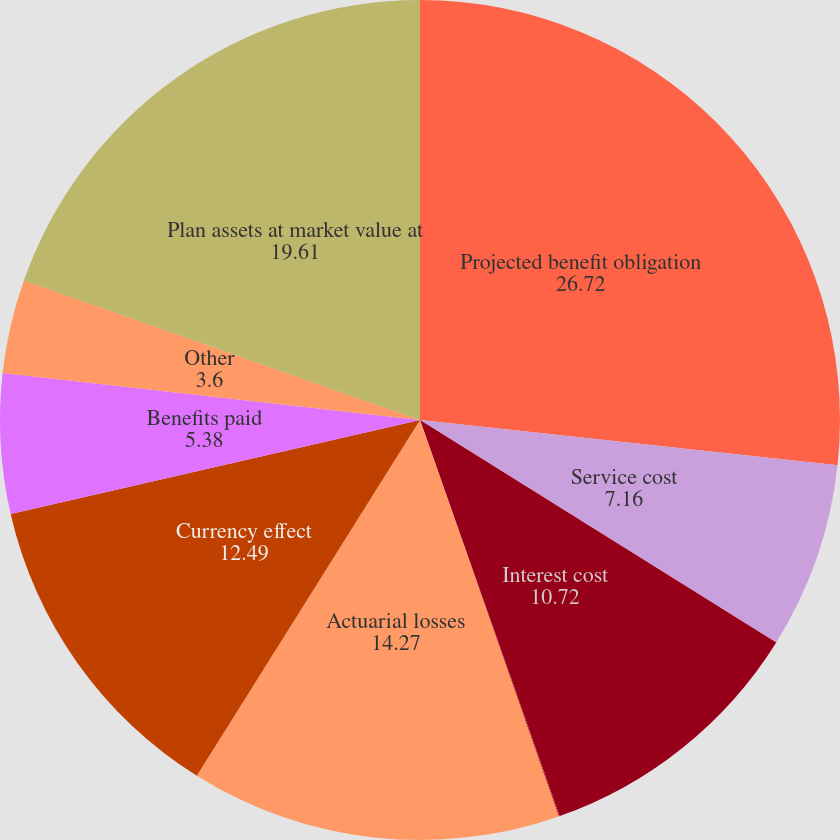Convert chart. <chart><loc_0><loc_0><loc_500><loc_500><pie_chart><fcel>Projected benefit obligation<fcel>Service cost<fcel>Interest cost<fcel>Contributions by Plan<fcel>Actuarial losses<fcel>Currency effect<fcel>Benefits paid<fcel>Other<fcel>Plan assets at market value at<nl><fcel>26.72%<fcel>7.16%<fcel>10.72%<fcel>0.04%<fcel>14.27%<fcel>12.49%<fcel>5.38%<fcel>3.6%<fcel>19.61%<nl></chart> 